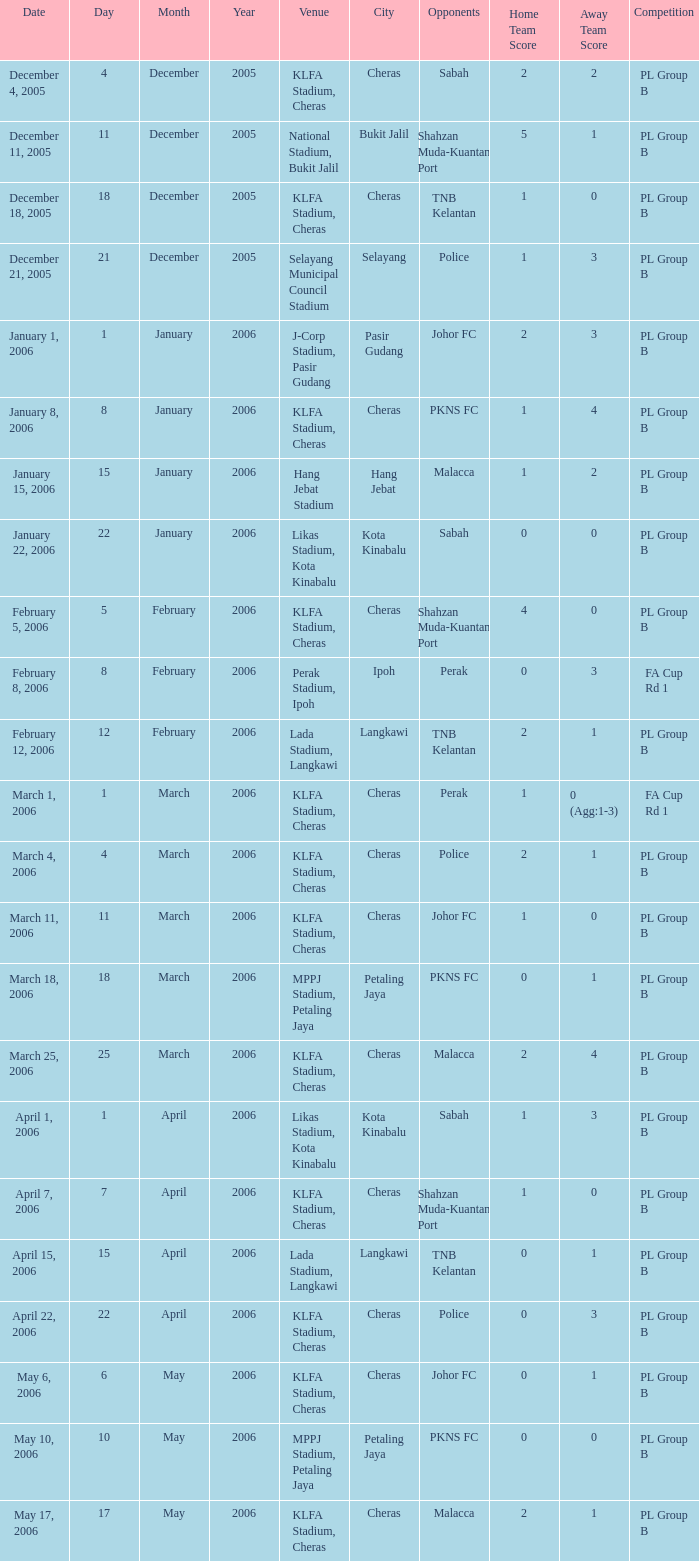Which Date has a Competition of pl group b, and Opponents of police, and a Venue of selayang municipal council stadium? December 21, 2005. Could you parse the entire table as a dict? {'header': ['Date', 'Day', 'Month', 'Year', 'Venue', 'City', 'Opponents', 'Home Team Score', 'Away Team Score', 'Competition'], 'rows': [['December 4, 2005', '4', 'December', '2005', 'KLFA Stadium, Cheras', 'Cheras', 'Sabah', '2', '2', 'PL Group B'], ['December 11, 2005', '11', 'December', '2005', 'National Stadium, Bukit Jalil', 'Bukit Jalil', 'Shahzan Muda-Kuantan Port', '5', '1', 'PL Group B'], ['December 18, 2005', '18', 'December', '2005', 'KLFA Stadium, Cheras', 'Cheras', 'TNB Kelantan', '1', '0', 'PL Group B'], ['December 21, 2005', '21', 'December', '2005', 'Selayang Municipal Council Stadium', 'Selayang', 'Police', '1', '3', 'PL Group B'], ['January 1, 2006', '1', 'January', '2006', 'J-Corp Stadium, Pasir Gudang', 'Pasir Gudang', 'Johor FC', '2', '3', 'PL Group B'], ['January 8, 2006', '8', 'January', '2006', 'KLFA Stadium, Cheras', 'Cheras', 'PKNS FC', '1', '4', 'PL Group B'], ['January 15, 2006', '15', 'January', '2006', 'Hang Jebat Stadium', 'Hang Jebat', 'Malacca', '1', '2', 'PL Group B'], ['January 22, 2006', '22', 'January', '2006', 'Likas Stadium, Kota Kinabalu', 'Kota Kinabalu', 'Sabah', '0', '0', 'PL Group B'], ['February 5, 2006', '5', 'February', '2006', 'KLFA Stadium, Cheras', 'Cheras', 'Shahzan Muda-Kuantan Port', '4', '0', 'PL Group B'], ['February 8, 2006', '8', 'February', '2006', 'Perak Stadium, Ipoh', 'Ipoh', 'Perak', '0', '3', 'FA Cup Rd 1'], ['February 12, 2006', '12', 'February', '2006', 'Lada Stadium, Langkawi', 'Langkawi', 'TNB Kelantan', '2', '1', 'PL Group B'], ['March 1, 2006', '1', 'March', '2006', 'KLFA Stadium, Cheras', 'Cheras', 'Perak', '1', '0 (Agg:1-3)', 'FA Cup Rd 1'], ['March 4, 2006', '4', 'March', '2006', 'KLFA Stadium, Cheras', 'Cheras', 'Police', '2', '1', 'PL Group B'], ['March 11, 2006', '11', 'March', '2006', 'KLFA Stadium, Cheras', 'Cheras', 'Johor FC', '1', '0', 'PL Group B'], ['March 18, 2006', '18', 'March', '2006', 'MPPJ Stadium, Petaling Jaya', 'Petaling Jaya', 'PKNS FC', '0', '1', 'PL Group B'], ['March 25, 2006', '25', 'March', '2006', 'KLFA Stadium, Cheras', 'Cheras', 'Malacca', '2', '4', 'PL Group B'], ['April 1, 2006', '1', 'April', '2006', 'Likas Stadium, Kota Kinabalu', 'Kota Kinabalu', 'Sabah', '1', '3', 'PL Group B'], ['April 7, 2006', '7', 'April', '2006', 'KLFA Stadium, Cheras', 'Cheras', 'Shahzan Muda-Kuantan Port', '1', '0', 'PL Group B'], ['April 15, 2006', '15', 'April', '2006', 'Lada Stadium, Langkawi', 'Langkawi', 'TNB Kelantan', '0', '1', 'PL Group B'], ['April 22, 2006', '22', 'April', '2006', 'KLFA Stadium, Cheras', 'Cheras', 'Police', '0', '3', 'PL Group B'], ['May 6, 2006', '6', 'May', '2006', 'KLFA Stadium, Cheras', 'Cheras', 'Johor FC', '0', '1', 'PL Group B'], ['May 10, 2006', '10', 'May', '2006', 'MPPJ Stadium, Petaling Jaya', 'Petaling Jaya', 'PKNS FC', '0', '0', 'PL Group B'], ['May 17, 2006', '17', 'May', '2006', 'KLFA Stadium, Cheras', 'Cheras', 'Malacca', '2', '1', 'PL Group B']]} 